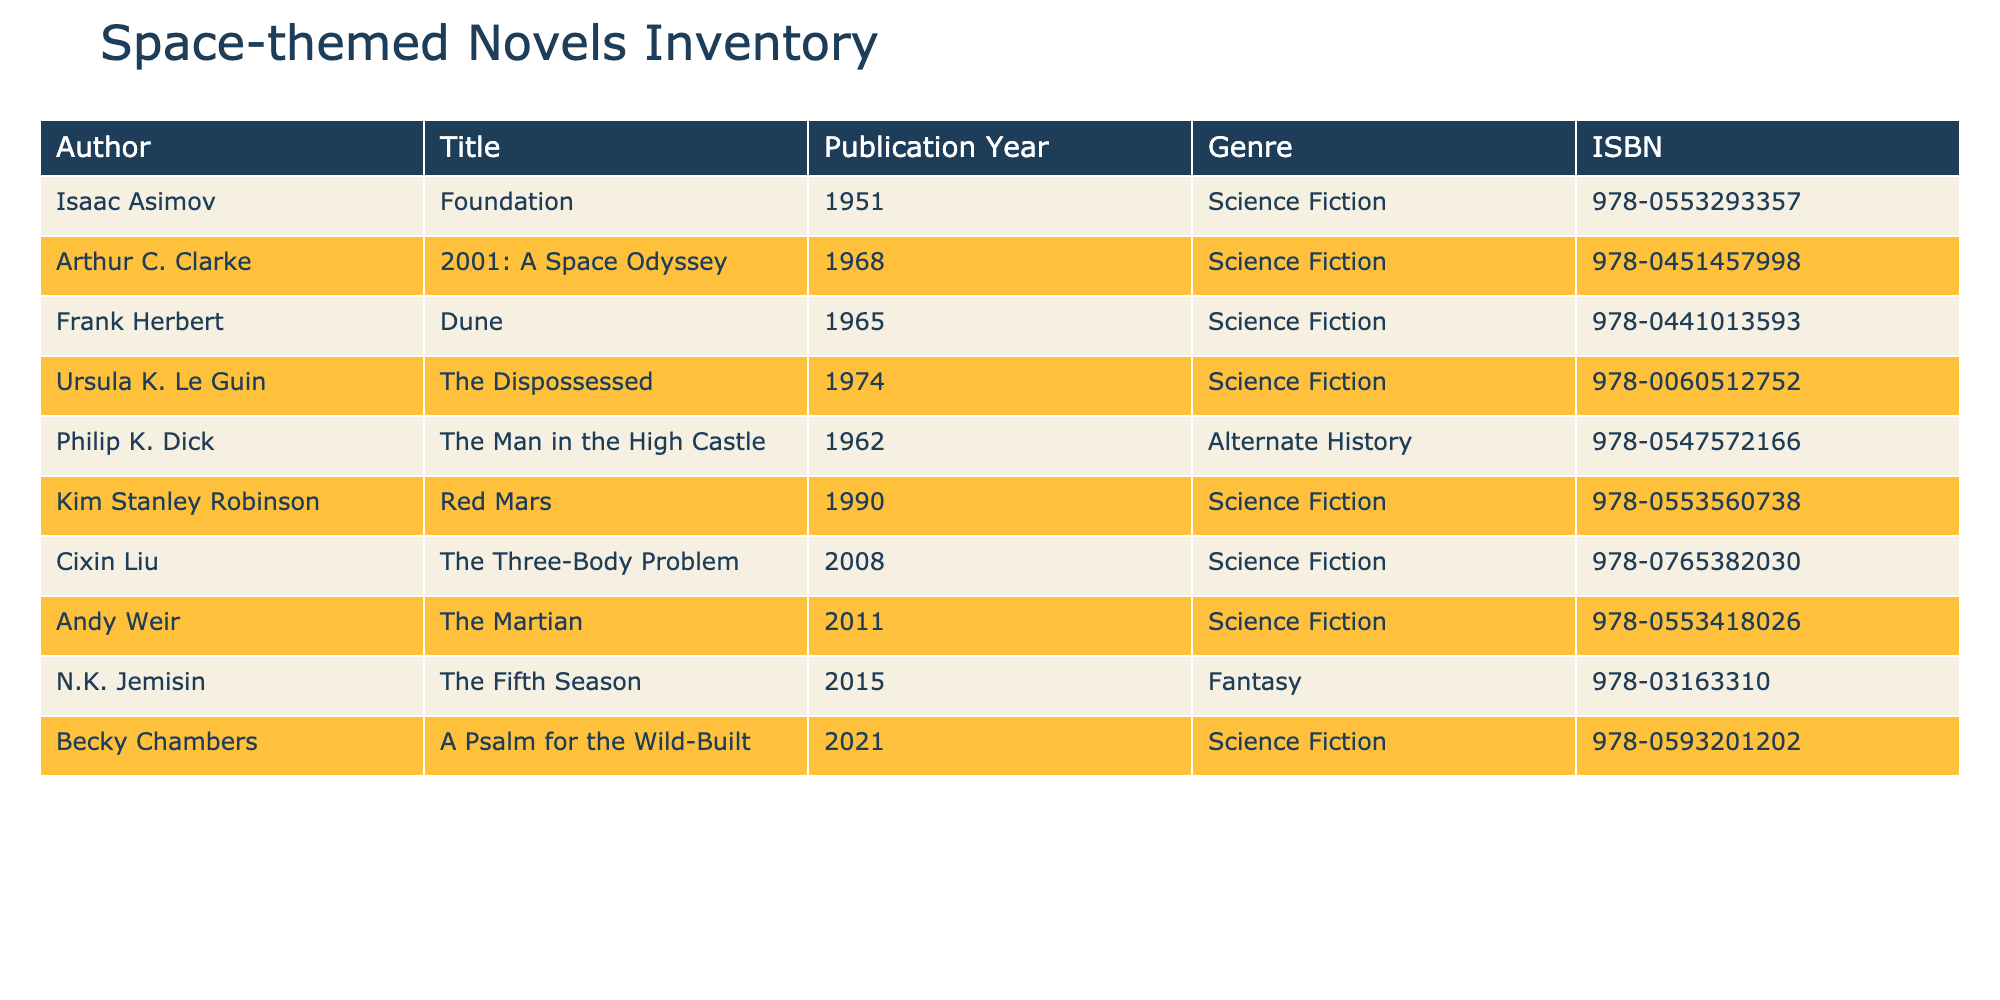What is the title of the novel by Isaac Asimov? The table lists the author Isaac Asimov alongside his work. The corresponding title in the same row shows "Foundation".
Answer: Foundation Which novel published in 2008 is authored by Cixin Liu? Referring to the 2008 entry in the table, we see that Cixin Liu's novel listed is "The Three-Body Problem".
Answer: The Three-Body Problem How many novels in the inventory were published before the year 1970? The table has novels from different years. We can identify the titles published before 1970 which are "Foundation", "Dune", "The Man in the High Castle", and "The Dispossessed". Thus, there are 4 novels published before 1970.
Answer: 4 Is "Red Mars" classified as Science Fiction? Looking at the row for "Red Mars" reveals that its genre is clearly noted as Science Fiction.
Answer: Yes Which author has the most recently published novel listed in the inventory? Among the publication years in the table, the most recent year is 2021, where we find "A Psalm for the Wild-Built" by Becky Chambers.
Answer: Becky Chambers 